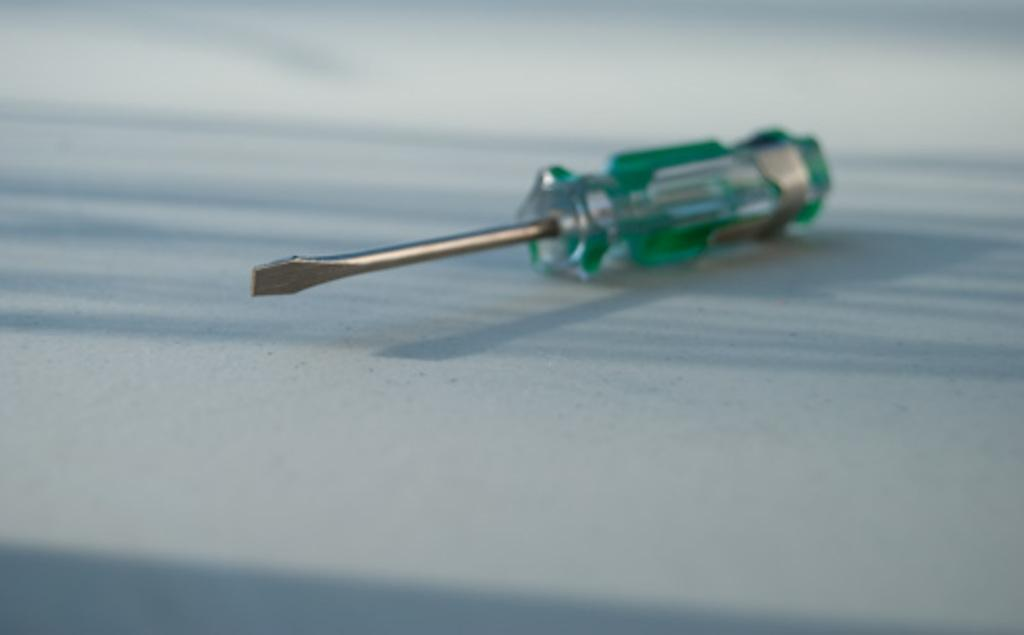What tool is present in the image? There is a screwdriver in the image. Where is the screwdriver located? The screwdriver is kept on the floor. What type of sofa can be seen in the image? There is no sofa present in the image; it only features a screwdriver on the floor. What is the purpose of the alarm in the image? There is no alarm present in the image. 